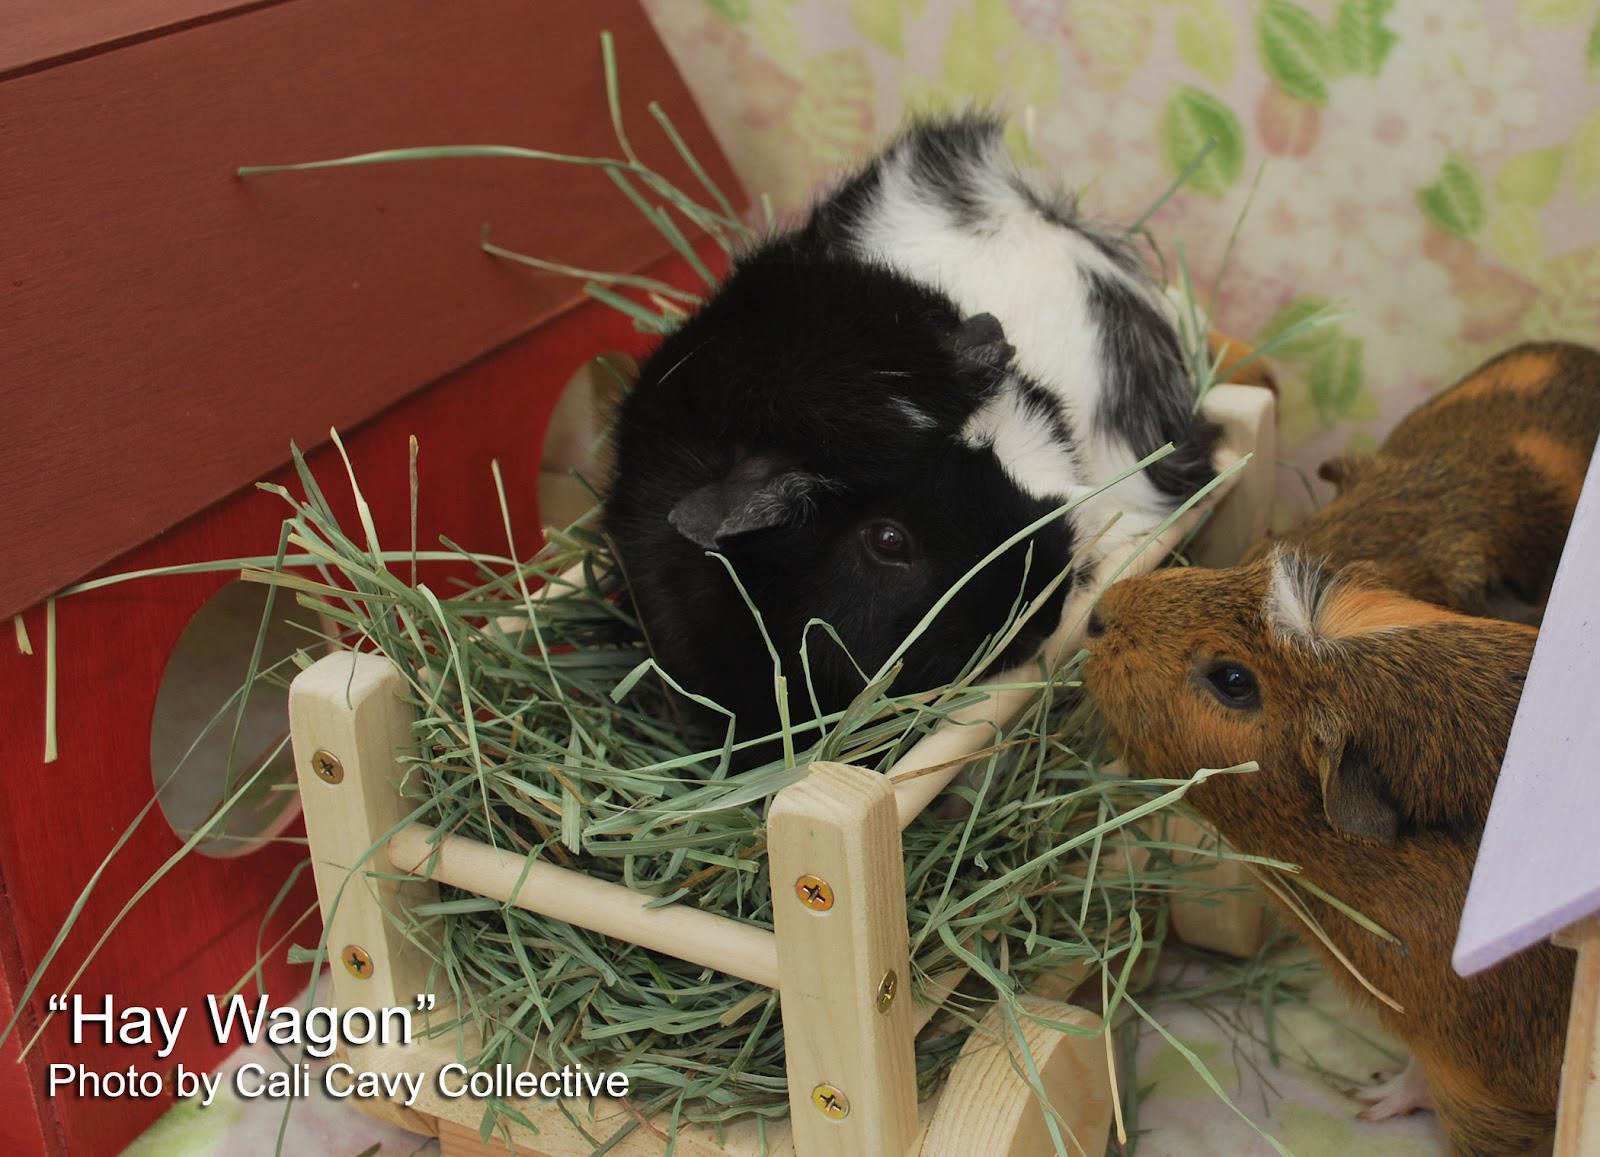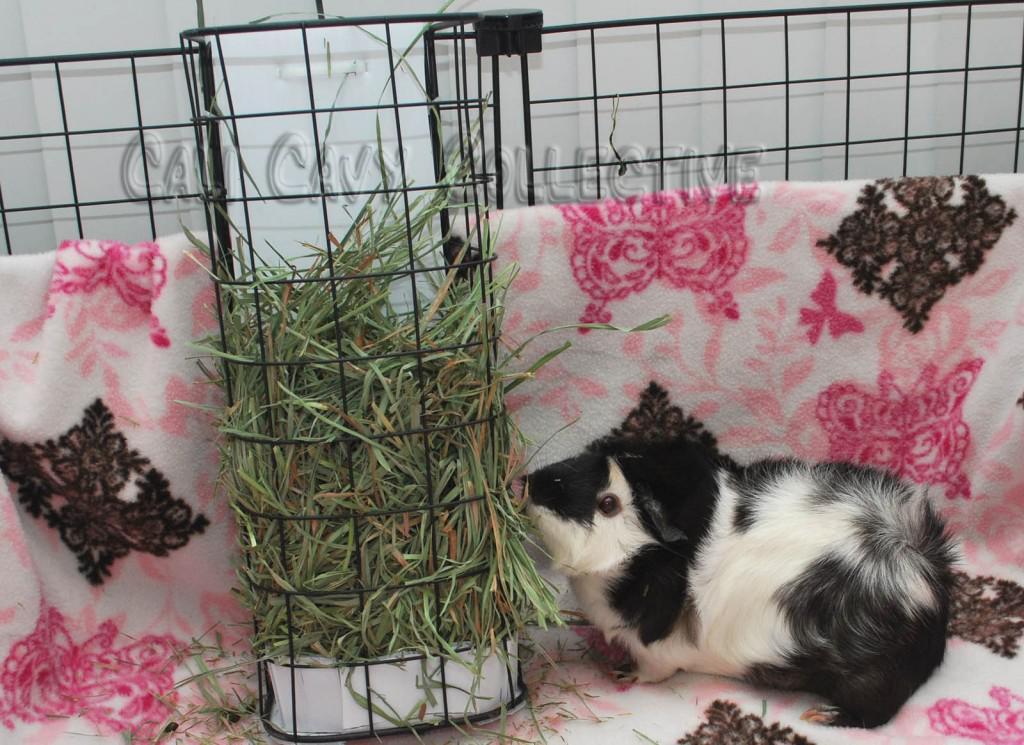The first image is the image on the left, the second image is the image on the right. Assess this claim about the two images: "One image shows a single hamster under a semi-circular arch, and the other image includes a hamster in a wheeled wooden wagon.". Correct or not? Answer yes or no. No. The first image is the image on the left, the second image is the image on the right. Considering the images on both sides, is "At least one image has a backdrop using a white blanket with pink and black designs on it." valid? Answer yes or no. Yes. 